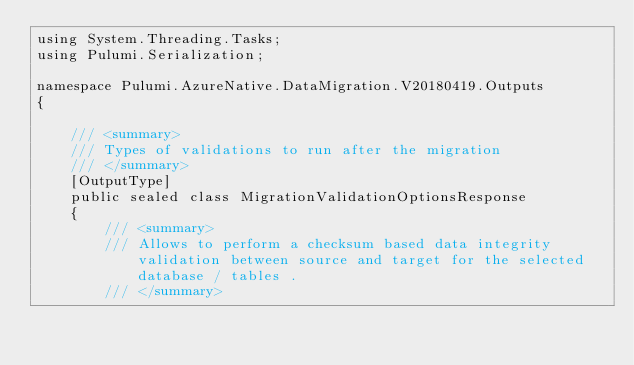Convert code to text. <code><loc_0><loc_0><loc_500><loc_500><_C#_>using System.Threading.Tasks;
using Pulumi.Serialization;

namespace Pulumi.AzureNative.DataMigration.V20180419.Outputs
{

    /// <summary>
    /// Types of validations to run after the migration
    /// </summary>
    [OutputType]
    public sealed class MigrationValidationOptionsResponse
    {
        /// <summary>
        /// Allows to perform a checksum based data integrity validation between source and target for the selected database / tables .
        /// </summary></code> 